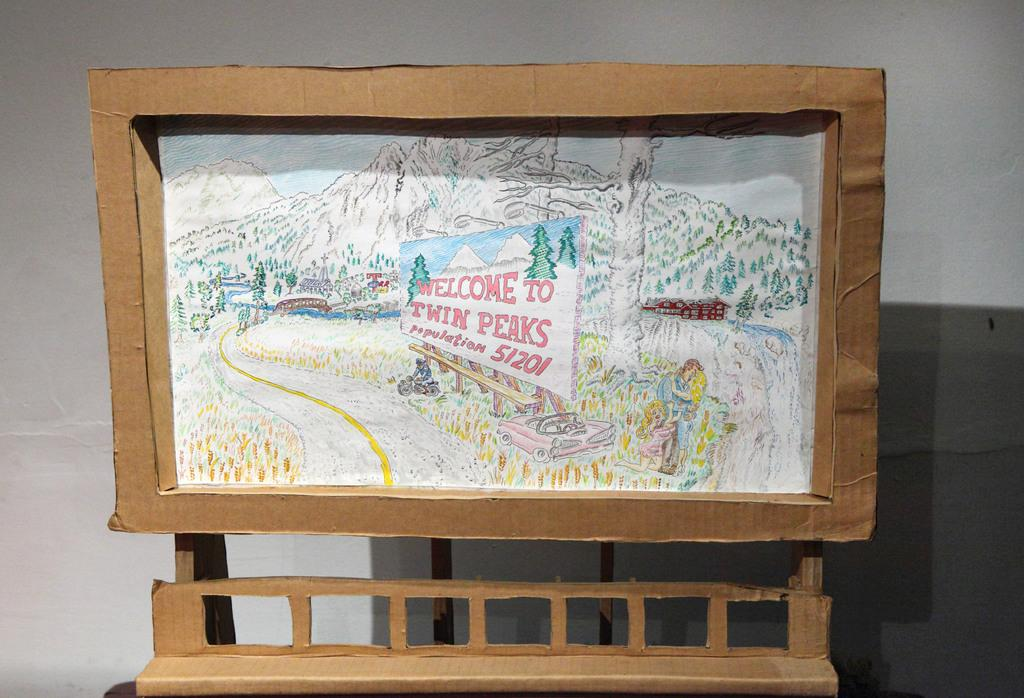<image>
Present a compact description of the photo's key features. A cardboard frame has a drawing of a mountain with a sign that says Welcome to Twin Peaks. 